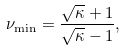Convert formula to latex. <formula><loc_0><loc_0><loc_500><loc_500>\nu _ { \min } = \frac { \sqrt { \kappa } + 1 } { \sqrt { \kappa } - 1 } ,</formula> 